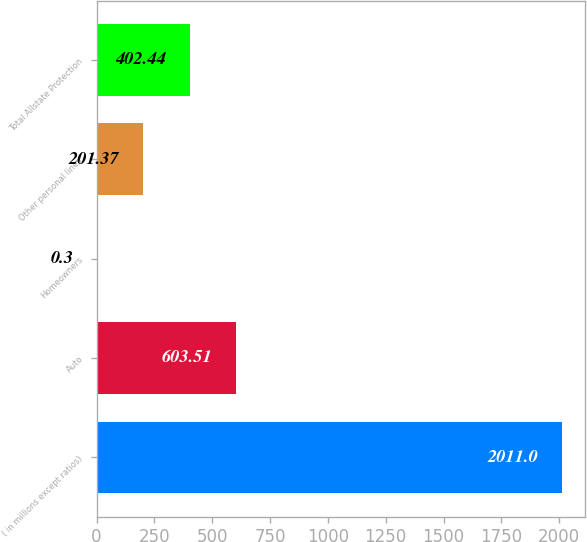<chart> <loc_0><loc_0><loc_500><loc_500><bar_chart><fcel>( in millions except ratios)<fcel>Auto<fcel>Homeowners<fcel>Other personal lines<fcel>Total Allstate Protection<nl><fcel>2011<fcel>603.51<fcel>0.3<fcel>201.37<fcel>402.44<nl></chart> 